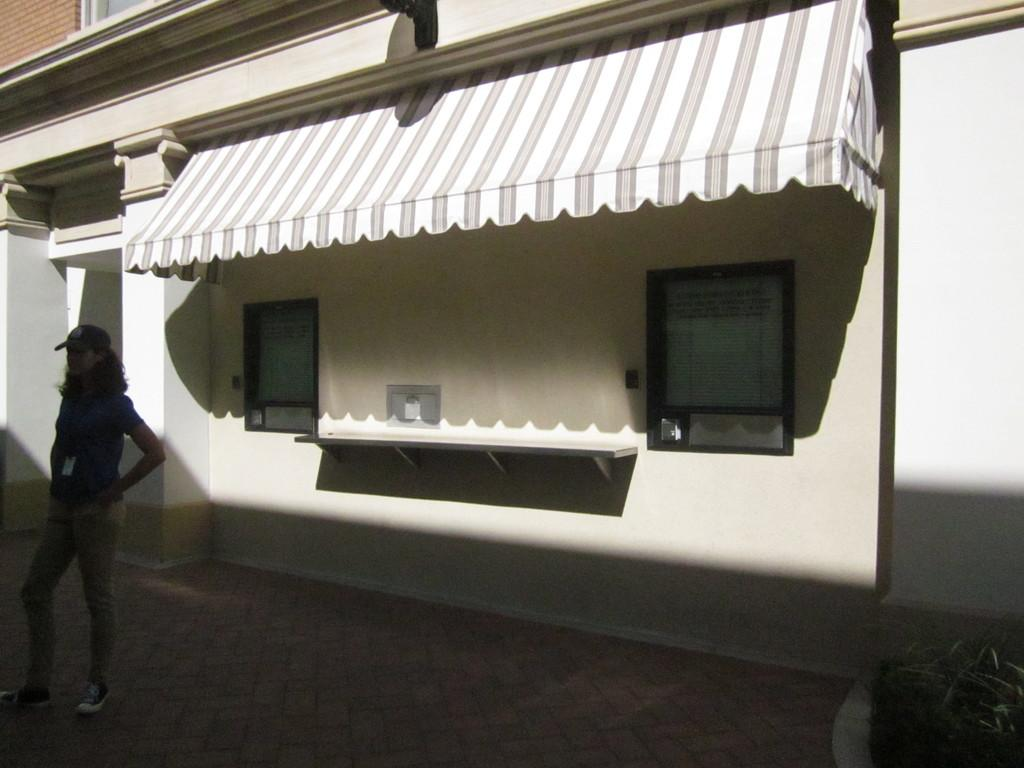Who is the main subject in the image? There is a woman in the image. What is the woman doing in the image? The woman is standing. What is the woman wearing on her head in the image? The woman is wearing a cap. What type of structure can be seen in the background of the image? There is a building with windows in the image. What is the time of day when the woman is participating in the protest in the image? There is no protest present in the image, and therefore no indication of the time of day. 